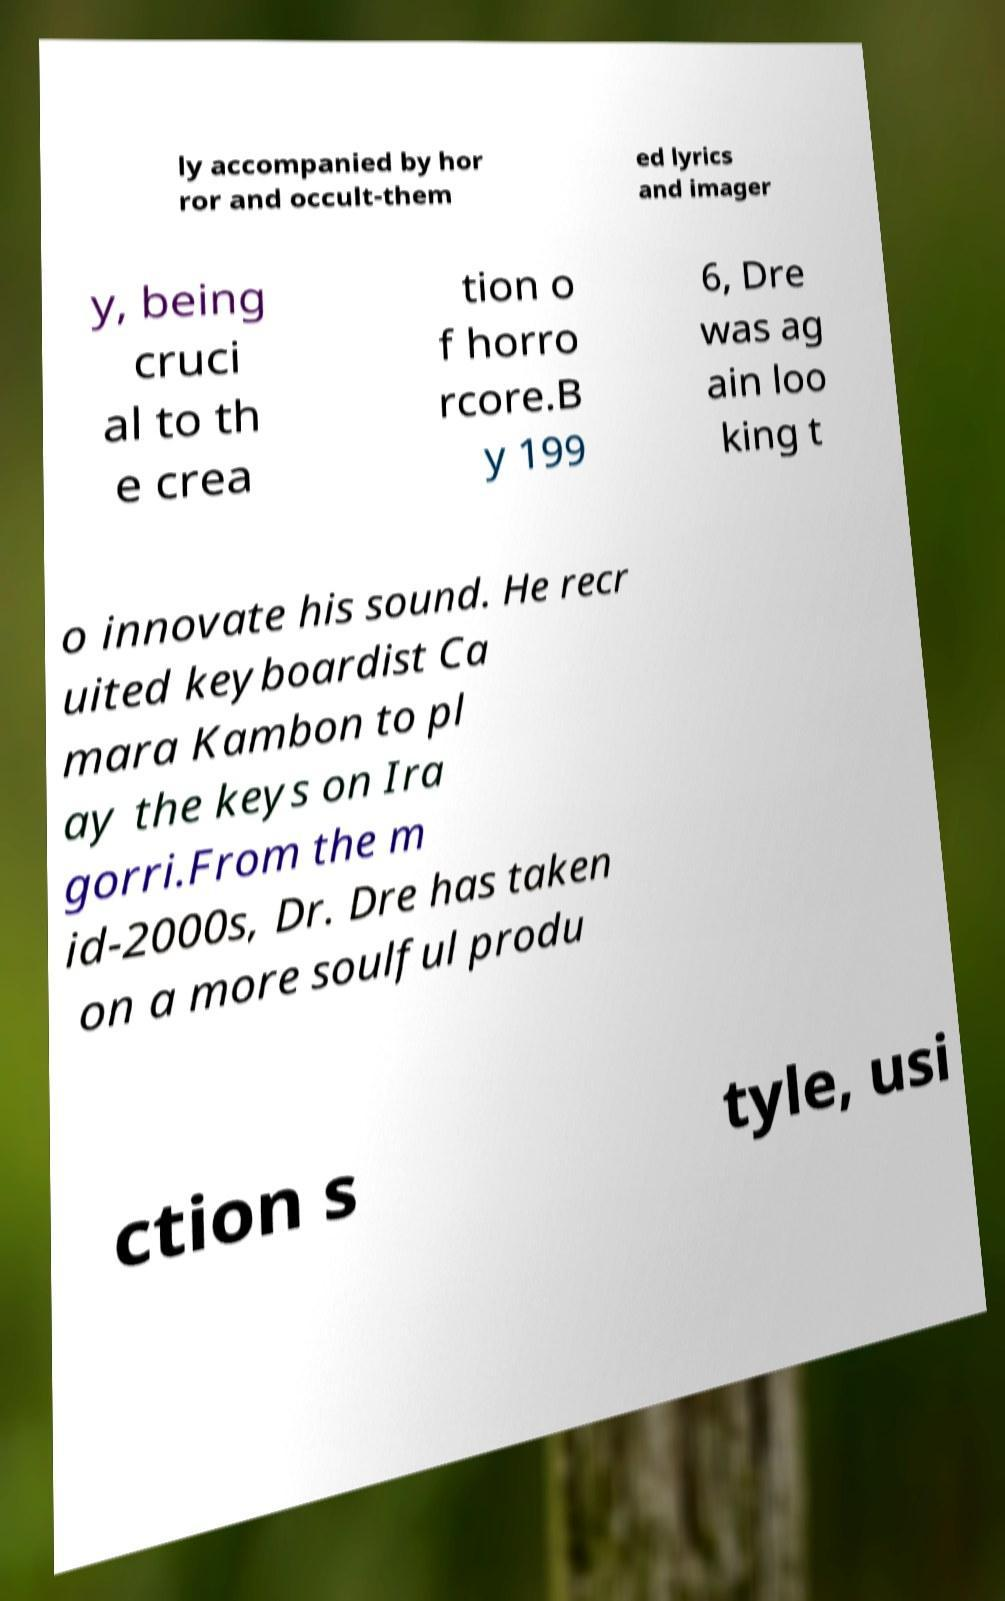Please identify and transcribe the text found in this image. ly accompanied by hor ror and occult-them ed lyrics and imager y, being cruci al to th e crea tion o f horro rcore.B y 199 6, Dre was ag ain loo king t o innovate his sound. He recr uited keyboardist Ca mara Kambon to pl ay the keys on Ira gorri.From the m id-2000s, Dr. Dre has taken on a more soulful produ ction s tyle, usi 